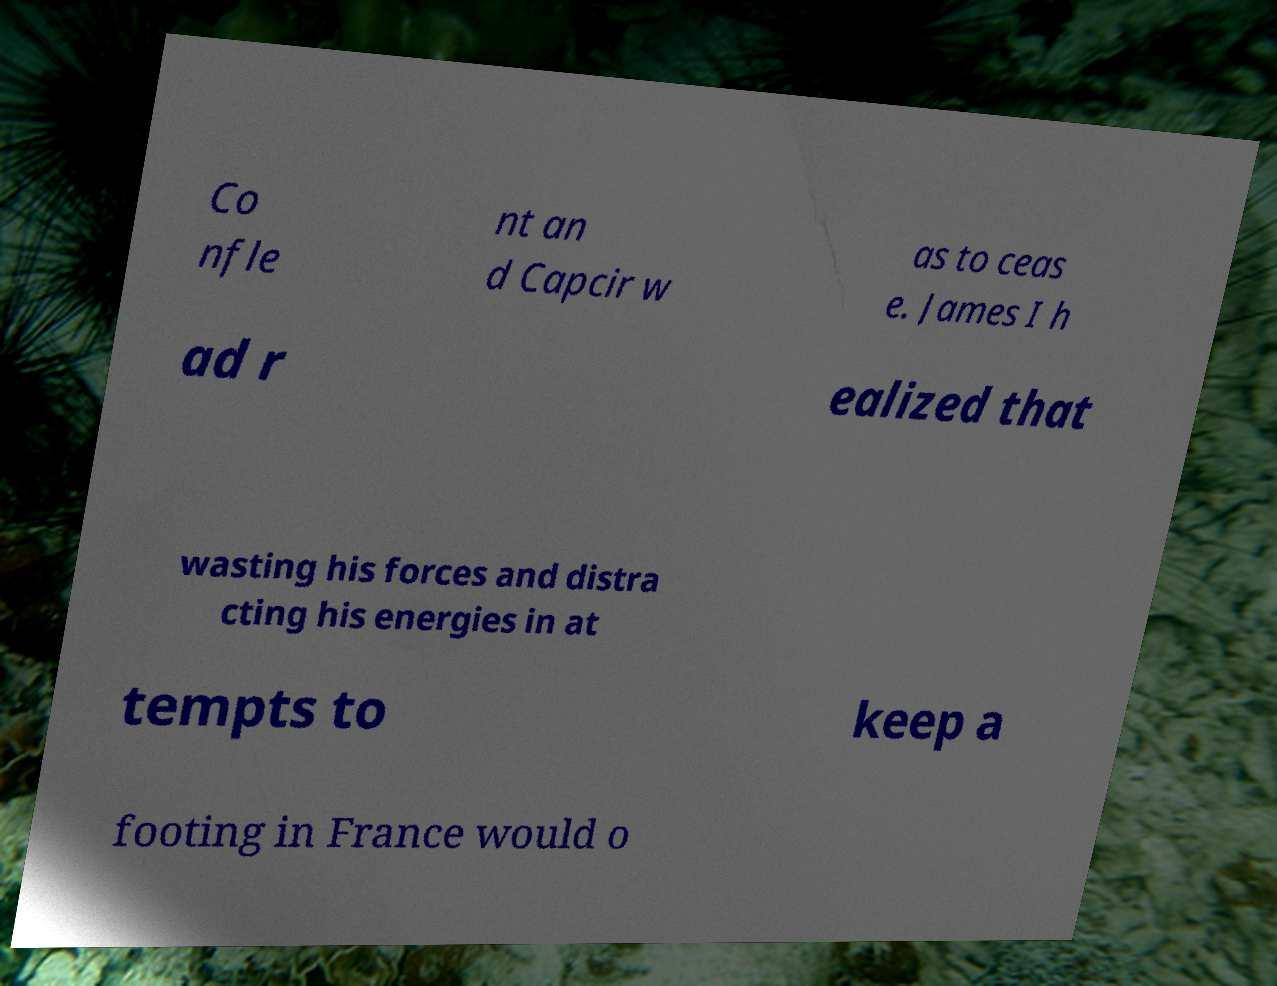Could you extract and type out the text from this image? Co nfle nt an d Capcir w as to ceas e. James I h ad r ealized that wasting his forces and distra cting his energies in at tempts to keep a footing in France would o 